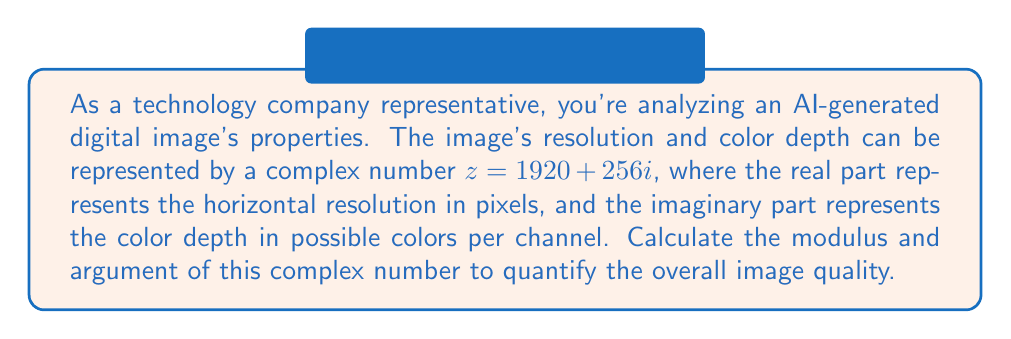Help me with this question. To solve this problem, we need to calculate the modulus and argument of the complex number $z = 1920 + 256i$.

1. Calculating the modulus:
The modulus of a complex number $z = a + bi$ is given by the formula:

$$ |z| = \sqrt{a^2 + b^2} $$

In this case, $a = 1920$ and $b = 256$. Let's substitute these values:

$$ |z| = \sqrt{1920^2 + 256^2} $$
$$ |z| = \sqrt{3,686,400 + 65,536} $$
$$ |z| = \sqrt{3,751,936} $$
$$ |z| \approx 1936.99 $$

2. Calculating the argument:
The argument of a complex number $z = a + bi$ is given by the formula:

$$ \arg(z) = \tan^{-1}\left(\frac{b}{a}\right) $$

Substituting our values:

$$ \arg(z) = \tan^{-1}\left(\frac{256}{1920}\right) $$
$$ \arg(z) = \tan^{-1}(0.1333...) $$
$$ \arg(z) \approx 0.1324 \text{ radians} $$

To convert radians to degrees, multiply by $\frac{180}{\pi}$:

$$ \arg(z) \approx 0.1324 \times \frac{180}{\pi} \approx 7.59^\circ $$
Answer: The modulus of the complex number is approximately 1936.99, and the argument is approximately 0.1324 radians or 7.59 degrees. 